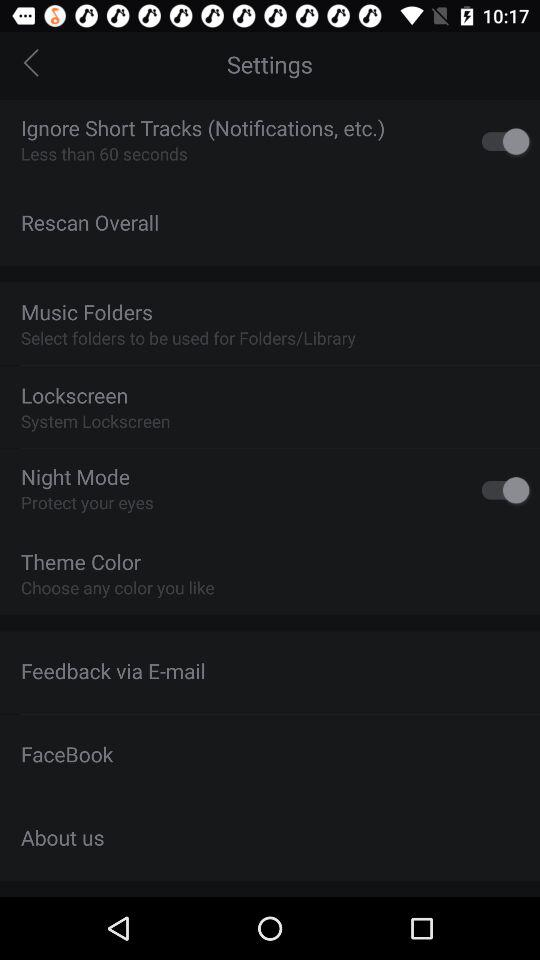What is the current status of "Ignore Short Tracks"? The current status is on. 